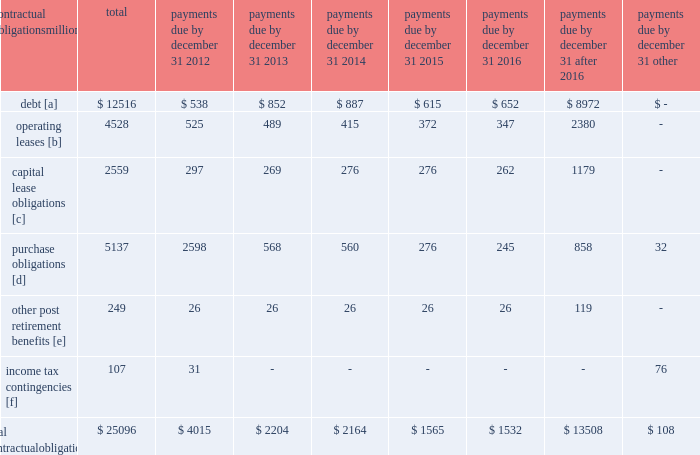The railroad collected approximately $ 18.8 billion and $ 16.3 billion of receivables during the years ended december 31 , 2011 and 2010 , respectively .
Upri used certain of these proceeds to purchase new receivables under the facility .
The costs of the receivables securitization facility include interest , which will vary based on prevailing commercial paper rates , program fees paid to banks , commercial paper issuing costs , and fees for unused commitment availability .
The costs of the receivables securitization facility are included in interest expense and were $ 4 million and $ 6 million for 2011 and 2010 , respectively .
Prior to adoption of the new accounting standard , the costs of the receivables securitization facility were included in other income and were $ 9 million for 2009 .
The investors have no recourse to the railroad 2019s other assets , except for customary warranty and indemnity claims .
Creditors of the railroad do not have recourse to the assets of upri .
In august 2011 , the receivables securitization facility was renewed for an additional 364-day period at comparable terms and conditions .
Contractual obligations and commercial commitments as described in the notes to the consolidated financial statements and as referenced in the tables below , we have contractual obligations and commercial commitments that may affect our financial condition .
Based on our assessment of the underlying provisions and circumstances of our contractual obligations and commercial commitments , including material sources of off-balance sheet and structured finance arrangements , other than the risks that we and other similarly situated companies face with respect to the condition of the capital markets ( as described in item 1a of part ii of this report ) , there is no known trend , demand , commitment , event , or uncertainty that is reasonably likely to occur that would have a material adverse effect on our consolidated results of operations , financial condition , or liquidity .
In addition , our commercial obligations , financings , and commitments are customary transactions that are similar to those of other comparable corporations , particularly within the transportation industry .
The tables identify material obligations and commitments as of december 31 , 2011 : payments due by december 31 , contractual obligations after millions total 2012 2013 2014 2015 2016 2016 other .
[a] excludes capital lease obligations of $ 1874 million and unamortized discount of $ 364 million .
Includes an interest component of $ 5120 million .
[b] includes leases for locomotives , freight cars , other equipment , and real estate .
[c] represents total obligations , including interest component of $ 685 million .
[d] purchase obligations include locomotive maintenance contracts ; purchase commitments for fuel purchases , locomotives , ties , ballast , and rail ; and agreements to purchase other goods and services .
For amounts where we cannot reasonably estimate the year of settlement , they are reflected in the other column .
[e] includes estimated other post retirement , medical , and life insurance payments and payments made under the unfunded pension plan for the next ten years .
No amounts are included for funded pension obligations as no contributions are currently required .
[f] future cash flows for income tax contingencies reflect the recorded liability for unrecognized tax benefits , including interest and penalties , as of december 31 , 2011 .
Where we can reasonably estimate the years in which these liabilities may be settled , this is shown in the table .
For amounts where we cannot reasonably estimate the year of settlement , they are reflected in the other column. .
Assuming 4 inventory turns per year , what would q12012 cash flow be from the receivables balance on december 31 , 2011 , in billions? 
Computations: (18.8 / 4)
Answer: 4.7. 